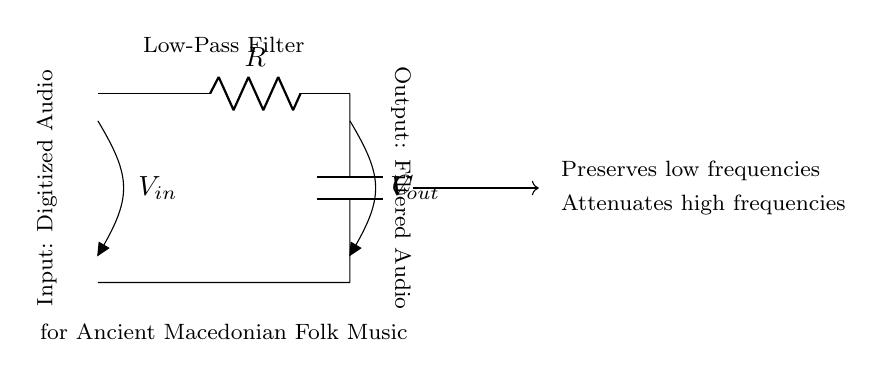What is the type of filter represented in the circuit? The circuit is a low-pass filter, which allows low frequencies to pass through while attenuating high frequencies. This is evident from the designation in the circuit.
Answer: low-pass filter What are the components used in the circuit? The circuit diagram shows two key components: a resistor and a capacitor, labeled as R and C respectively. These components are typically used in low-pass filters.
Answer: resistor and capacitor What does V_in represent in the circuit? In the circuit, V_in denotes the input voltage, which is the signal that is to be filtered. It indicates where the digitized audio enters the low-pass filter.
Answer: input voltage What does V_out represent in the circuit? V_out represents the output voltage, which is the filtered audio after passing through the low-pass filter. It shows the voltage after attenuation of high frequencies.
Answer: output voltage What is the purpose of the low-pass filter in this circuit? The purpose of the low-pass filter in this circuit is to preserve low frequencies while attenuating higher frequencies, which is crucial for retaining the quality of ancient folk music recordings.
Answer: preserve low frequencies Why is a low-pass filter important for traditional Macedonian folk music? A low-pass filter is important for traditional Macedonian folk music because it enhances the lower frequency components, which are essential for the sound characteristics of the music, ensuring that the recordings maintain their authenticity.
Answer: enhance lower frequencies What happens to high frequencies in this filter? High frequencies are attenuated in this filter, meaning they are reduced in amplitude or strength as they pass through, allowing primarily low frequencies to be outputted.
Answer: attenuated 